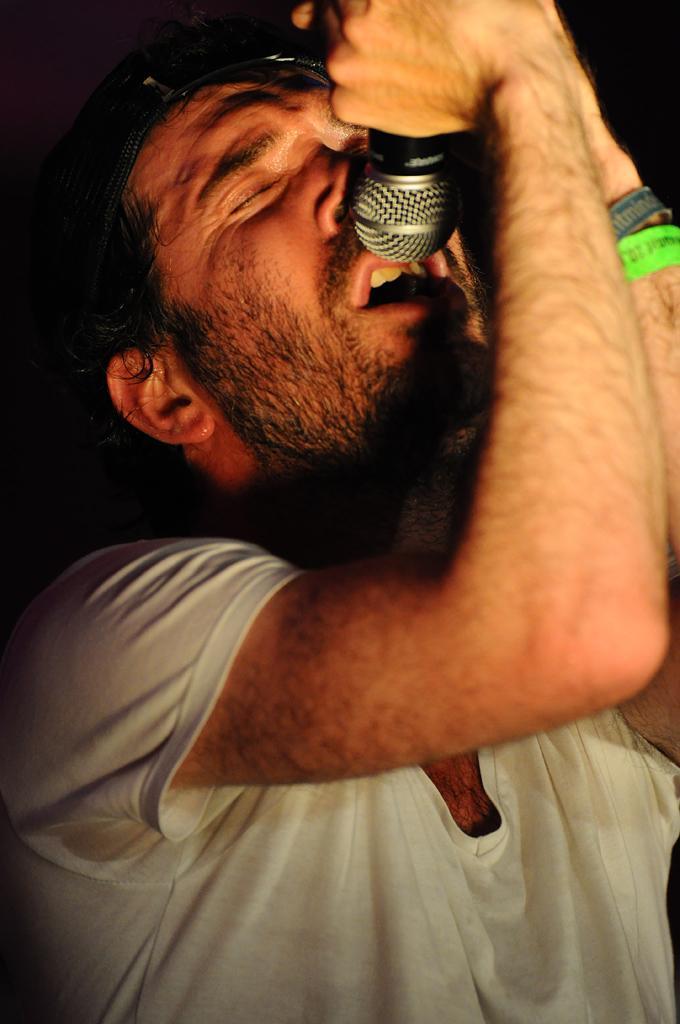Please provide a concise description of this image. In this image i can see a person holding a microphone in his hands. 